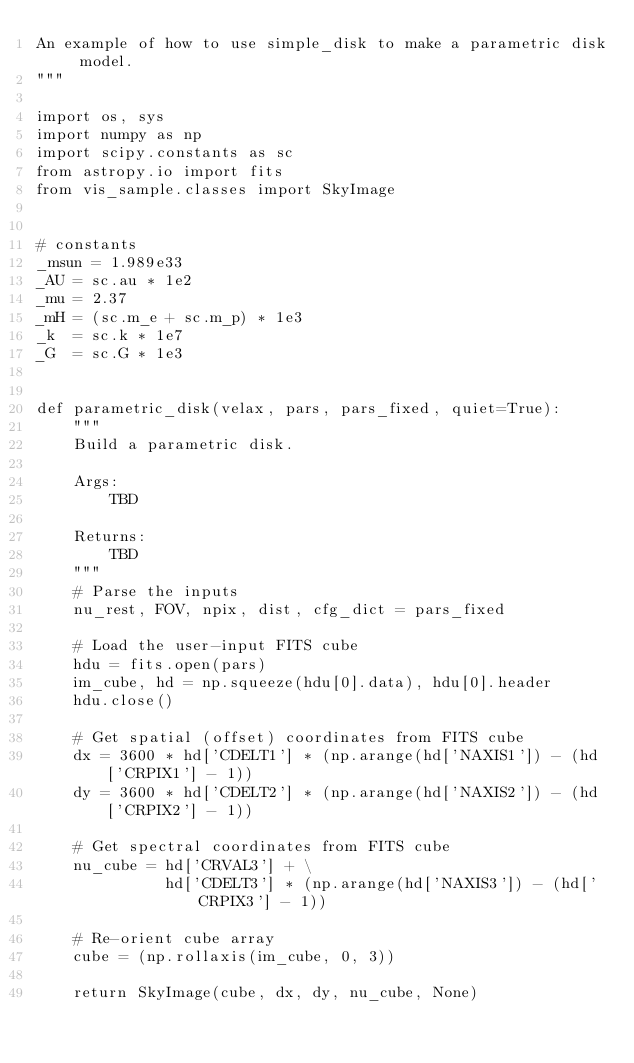<code> <loc_0><loc_0><loc_500><loc_500><_Python_>An example of how to use simple_disk to make a parametric disk model.
"""

import os, sys
import numpy as np
import scipy.constants as sc
from astropy.io import fits
from vis_sample.classes import SkyImage


# constants
_msun = 1.989e33
_AU = sc.au * 1e2
_mu = 2.37
_mH = (sc.m_e + sc.m_p) * 1e3
_k  = sc.k * 1e7
_G  = sc.G * 1e3


def parametric_disk(velax, pars, pars_fixed, quiet=True):
    """
    Build a parametric disk.

    Args:
        TBD

    Returns:
        TBD
    """
    # Parse the inputs
    nu_rest, FOV, npix, dist, cfg_dict = pars_fixed

    # Load the user-input FITS cube
    hdu = fits.open(pars)
    im_cube, hd = np.squeeze(hdu[0].data), hdu[0].header
    hdu.close()

    # Get spatial (offset) coordinates from FITS cube
    dx = 3600 * hd['CDELT1'] * (np.arange(hd['NAXIS1']) - (hd['CRPIX1'] - 1))
    dy = 3600 * hd['CDELT2'] * (np.arange(hd['NAXIS2']) - (hd['CRPIX2'] - 1))

    # Get spectral coordinates from FITS cube
    nu_cube = hd['CRVAL3'] + \
              hd['CDELT3'] * (np.arange(hd['NAXIS3']) - (hd['CRPIX3'] - 1))

    # Re-orient cube array
    cube = (np.rollaxis(im_cube, 0, 3))

    return SkyImage(cube, dx, dy, nu_cube, None)
</code> 